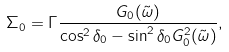<formula> <loc_0><loc_0><loc_500><loc_500>\Sigma _ { 0 } = \Gamma \frac { G _ { 0 } ( \tilde { \omega } ) } { \cos ^ { 2 } \delta _ { 0 } - \sin ^ { 2 } \delta _ { 0 } G ^ { 2 } _ { 0 } ( \tilde { \omega } ) } ,</formula> 